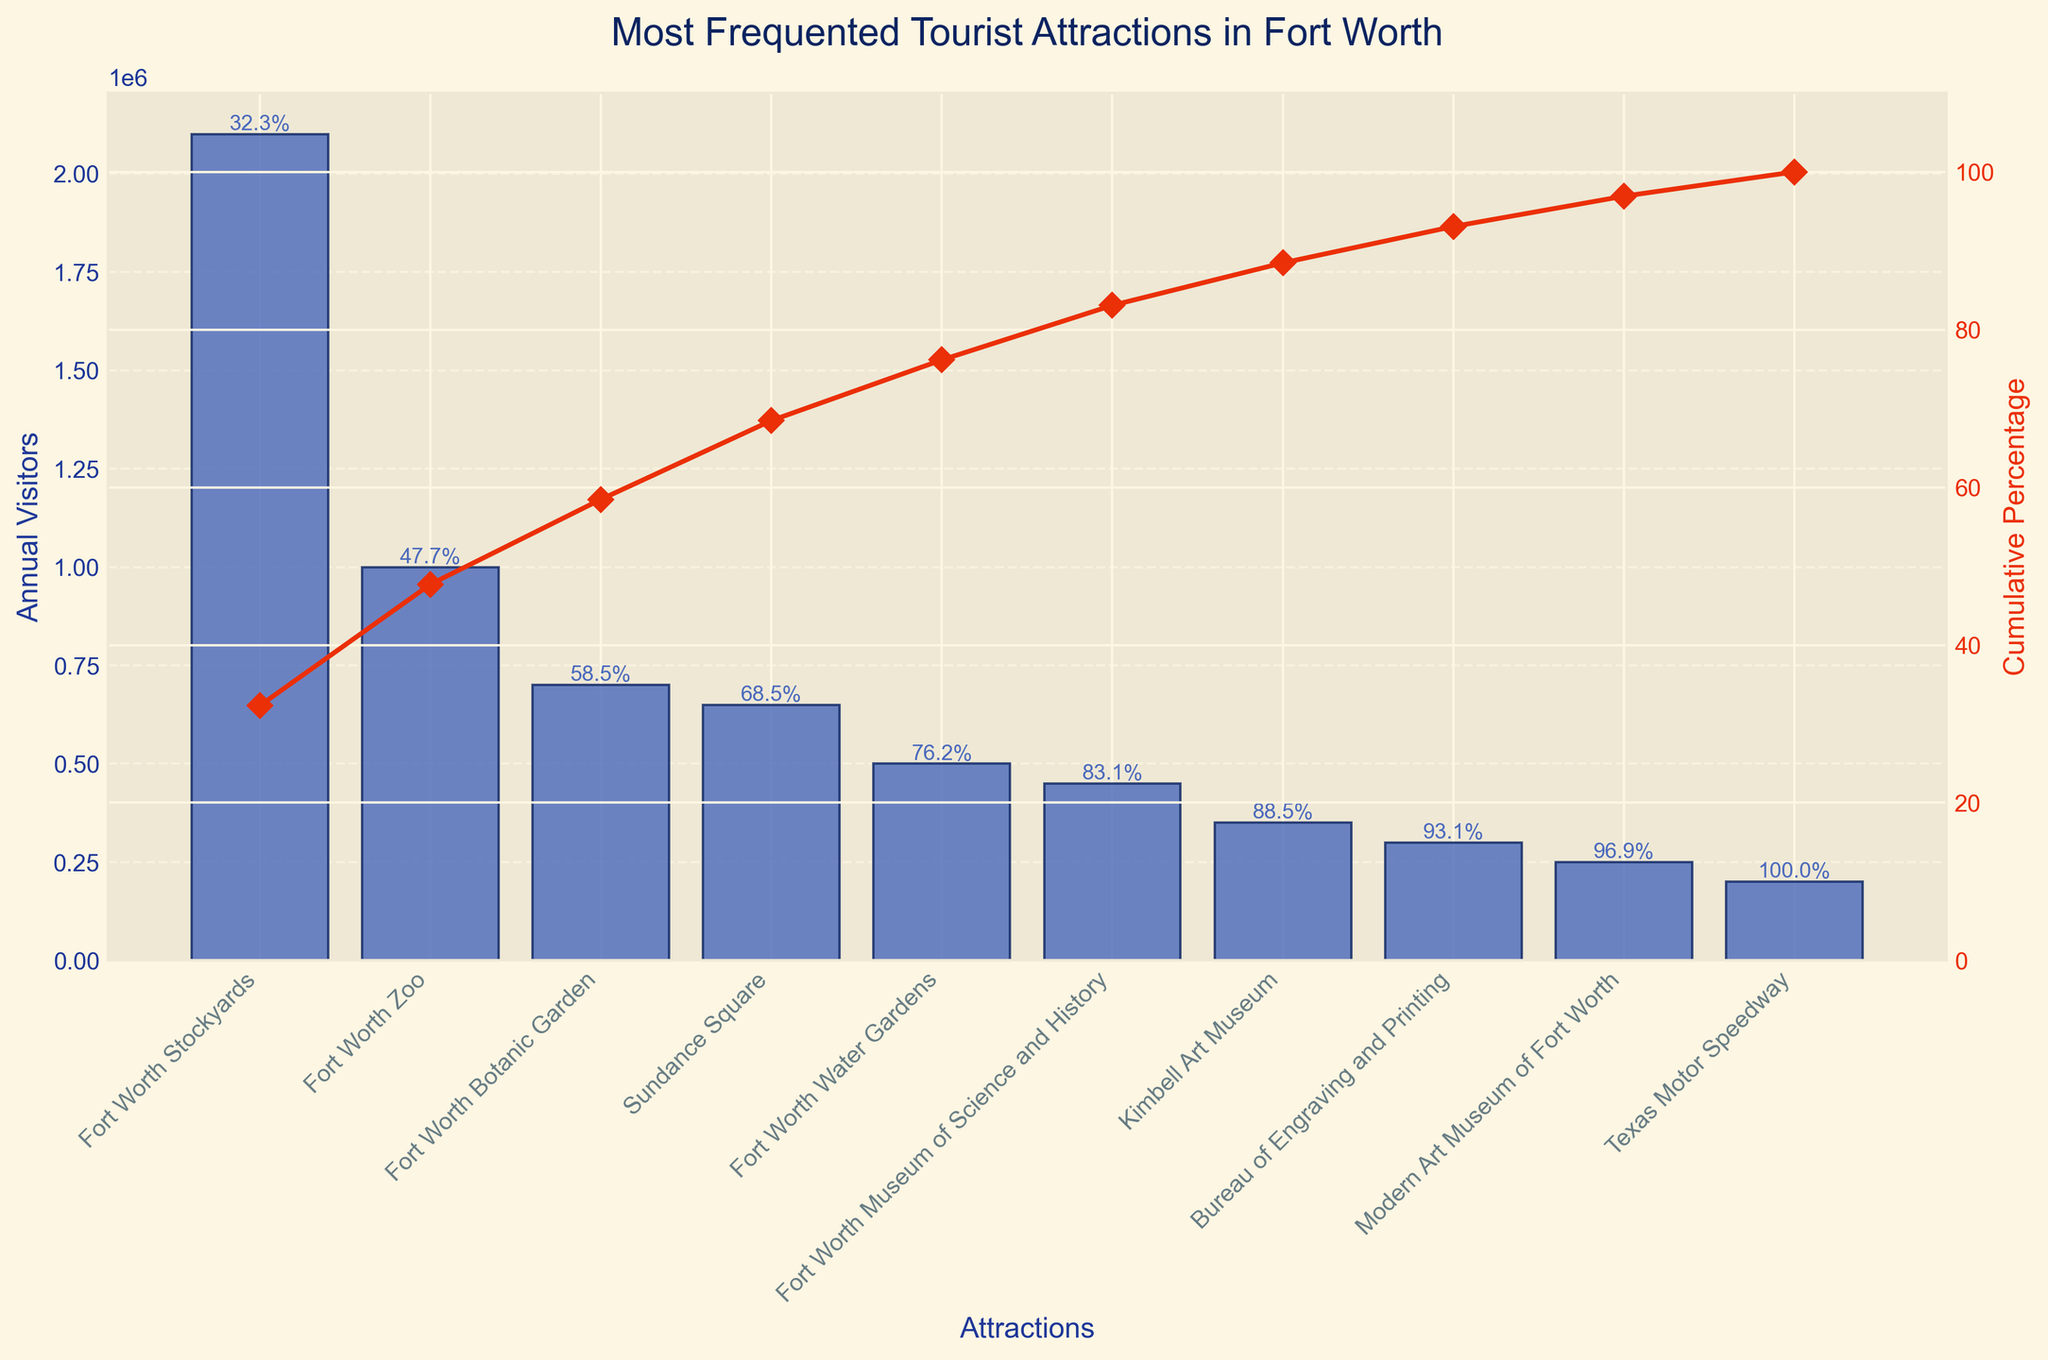What's the most visited tourist attraction in Fort Worth? The title of the plot indicates the chart shows the most frequented tourist attractions in Fort Worth. The highest bar in the chart belongs to the Fort Worth Stockyards, with its corresponding visitor count at the top of the chart.
Answer: Fort Worth Stockyards What is the title of the chart? The title of the chart is displayed at the top of the figure.
Answer: Most Frequented Tourist Attractions in Fort Worth How many annual visitors does the Fort Worth Zoo have? Locate the Fort Worth Zoo along the x-axis and read the height of the bar on the y-axis, which corresponds to the number of annual visitors.
Answer: 1,000,000 By how much do the annual visitors for the Fort Worth Botanic Garden differ from those for Sundance Square? First, find the annual visitors for both attractions: the Fort Worth Botanic Garden has 700,000 visitors, and Sundance Square has 650,000 visitors. Then subtract the smaller figure from the larger one: 700,000 - 650,000.
Answer: 50,000 Which attraction has the least number of annual visitors and how many does it have? The smallest bar on the chart represents the attraction with the least visitors, which is the Texas Motor Speedway. Look at its height on the y-axis for the count.
Answer: Texas Motor Speedway, 200,000 What is the cumulative percentage of annual visitors up to the Fort Worth Water Gardens? Locate the Fort Worth Water Gardens on the chart and look for the cumulative percentage line (red line) corresponding to it. Read the value either from the annotation above the bar or from the second y-axis.
Answer: 78.9% How many attractions have more than 500,000 annual visitors? Locate the bars that reach above 500,000 visitors on the y-axis. Count these bars to find how many exceed 500,000 annual visitors.
Answer: 4 attractions If you sum the annual visitors of the Fort Worth Stockyards, Fort Worth Zoo, and Fort Worth Botanic Garden, what is the total? Add the annual visitor counts for these attractions: 2,100,000 (Fort Worth Stockyards) + 1,000,000 (Fort Worth Zoo) + 700,000 (Fort Worth Botanic Garden). The result is the total combined visitors.
Answer: 3,800,000 Which attraction contributes to the steepest increase in the cumulative percentage and what is that increase? Identify the attraction with the steepest slope in the cumulative percentage curve. The steepest increase occurs immediately after the Fort Worth Stockyards, which shows the largest jump from 0% to 42.2%.
Answer: Fort Worth Stockyards, 42.2% Is there any attraction whose entry contributes exactly 10% or more to the total annual visitors after summing up from the order? Examine the cumulative percentage values to see if multiple entries reach a new cumulative total adding 10% or more. Since the Fort Worth Stockyards contribute 42.2% alone, it's clear that adding any individual entry afterward does not hit another exact 10% mark altogether.
Answer: No 